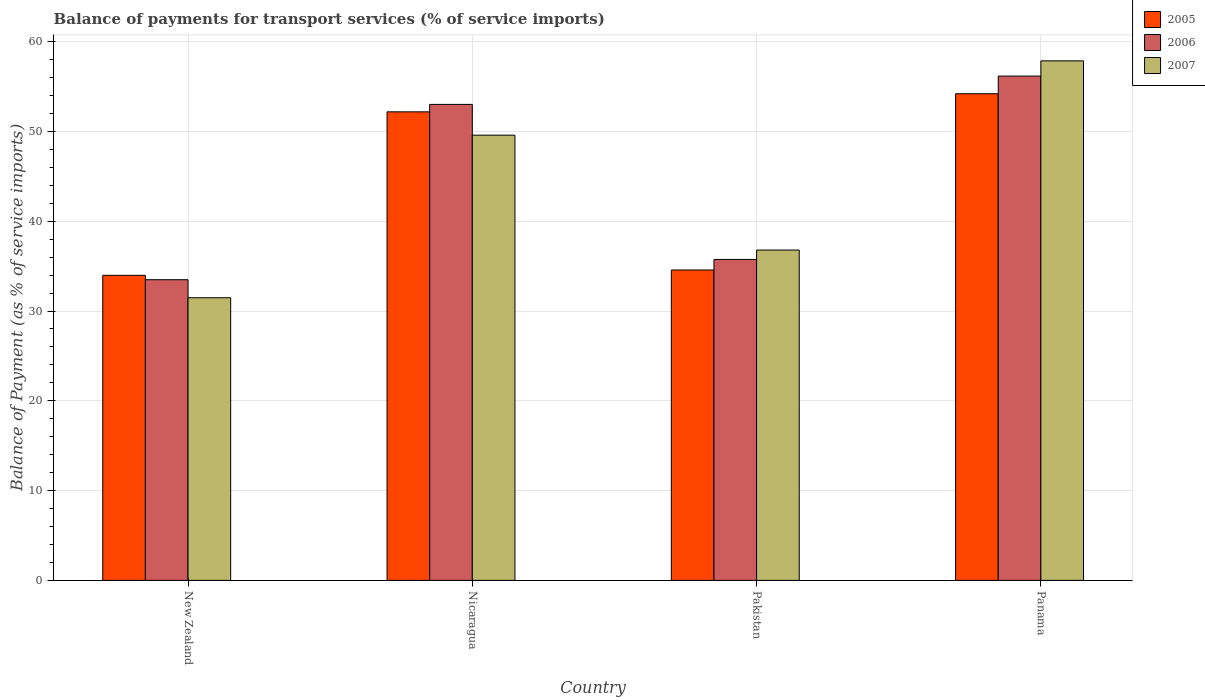How many different coloured bars are there?
Offer a very short reply. 3. Are the number of bars on each tick of the X-axis equal?
Give a very brief answer. Yes. How many bars are there on the 1st tick from the left?
Offer a terse response. 3. How many bars are there on the 1st tick from the right?
Give a very brief answer. 3. What is the label of the 2nd group of bars from the left?
Make the answer very short. Nicaragua. What is the balance of payments for transport services in 2005 in Panama?
Your response must be concise. 54.2. Across all countries, what is the maximum balance of payments for transport services in 2006?
Make the answer very short. 56.17. Across all countries, what is the minimum balance of payments for transport services in 2007?
Ensure brevity in your answer.  31.48. In which country was the balance of payments for transport services in 2005 maximum?
Your answer should be compact. Panama. In which country was the balance of payments for transport services in 2006 minimum?
Offer a very short reply. New Zealand. What is the total balance of payments for transport services in 2006 in the graph?
Provide a short and direct response. 178.42. What is the difference between the balance of payments for transport services in 2006 in Nicaragua and that in Panama?
Offer a terse response. -3.15. What is the difference between the balance of payments for transport services in 2006 in Pakistan and the balance of payments for transport services in 2007 in New Zealand?
Your response must be concise. 4.27. What is the average balance of payments for transport services in 2007 per country?
Provide a short and direct response. 43.93. What is the difference between the balance of payments for transport services of/in 2006 and balance of payments for transport services of/in 2005 in Nicaragua?
Make the answer very short. 0.83. In how many countries, is the balance of payments for transport services in 2006 greater than 54 %?
Provide a short and direct response. 1. What is the ratio of the balance of payments for transport services in 2007 in Pakistan to that in Panama?
Provide a succinct answer. 0.64. Is the balance of payments for transport services in 2006 in New Zealand less than that in Pakistan?
Your response must be concise. Yes. What is the difference between the highest and the second highest balance of payments for transport services in 2007?
Provide a short and direct response. 21.07. What is the difference between the highest and the lowest balance of payments for transport services in 2005?
Give a very brief answer. 20.22. What does the 2nd bar from the left in Nicaragua represents?
Ensure brevity in your answer.  2006. Is it the case that in every country, the sum of the balance of payments for transport services in 2006 and balance of payments for transport services in 2005 is greater than the balance of payments for transport services in 2007?
Your answer should be compact. Yes. What is the difference between two consecutive major ticks on the Y-axis?
Keep it short and to the point. 10. Where does the legend appear in the graph?
Your answer should be compact. Top right. How are the legend labels stacked?
Provide a succinct answer. Vertical. What is the title of the graph?
Your answer should be compact. Balance of payments for transport services (% of service imports). Does "1966" appear as one of the legend labels in the graph?
Offer a terse response. No. What is the label or title of the Y-axis?
Keep it short and to the point. Balance of Payment (as % of service imports). What is the Balance of Payment (as % of service imports) of 2005 in New Zealand?
Provide a succinct answer. 33.98. What is the Balance of Payment (as % of service imports) of 2006 in New Zealand?
Make the answer very short. 33.49. What is the Balance of Payment (as % of service imports) in 2007 in New Zealand?
Your answer should be compact. 31.48. What is the Balance of Payment (as % of service imports) of 2005 in Nicaragua?
Offer a terse response. 52.19. What is the Balance of Payment (as % of service imports) of 2006 in Nicaragua?
Ensure brevity in your answer.  53.01. What is the Balance of Payment (as % of service imports) in 2007 in Nicaragua?
Make the answer very short. 49.59. What is the Balance of Payment (as % of service imports) in 2005 in Pakistan?
Give a very brief answer. 34.57. What is the Balance of Payment (as % of service imports) of 2006 in Pakistan?
Your answer should be very brief. 35.75. What is the Balance of Payment (as % of service imports) in 2007 in Pakistan?
Your response must be concise. 36.79. What is the Balance of Payment (as % of service imports) in 2005 in Panama?
Make the answer very short. 54.2. What is the Balance of Payment (as % of service imports) in 2006 in Panama?
Offer a terse response. 56.17. What is the Balance of Payment (as % of service imports) of 2007 in Panama?
Your answer should be very brief. 57.86. Across all countries, what is the maximum Balance of Payment (as % of service imports) in 2005?
Keep it short and to the point. 54.2. Across all countries, what is the maximum Balance of Payment (as % of service imports) in 2006?
Provide a succinct answer. 56.17. Across all countries, what is the maximum Balance of Payment (as % of service imports) of 2007?
Provide a succinct answer. 57.86. Across all countries, what is the minimum Balance of Payment (as % of service imports) in 2005?
Your answer should be compact. 33.98. Across all countries, what is the minimum Balance of Payment (as % of service imports) of 2006?
Provide a succinct answer. 33.49. Across all countries, what is the minimum Balance of Payment (as % of service imports) of 2007?
Your answer should be compact. 31.48. What is the total Balance of Payment (as % of service imports) in 2005 in the graph?
Ensure brevity in your answer.  174.94. What is the total Balance of Payment (as % of service imports) in 2006 in the graph?
Keep it short and to the point. 178.42. What is the total Balance of Payment (as % of service imports) in 2007 in the graph?
Offer a terse response. 175.72. What is the difference between the Balance of Payment (as % of service imports) of 2005 in New Zealand and that in Nicaragua?
Offer a very short reply. -18.21. What is the difference between the Balance of Payment (as % of service imports) in 2006 in New Zealand and that in Nicaragua?
Provide a short and direct response. -19.53. What is the difference between the Balance of Payment (as % of service imports) in 2007 in New Zealand and that in Nicaragua?
Your response must be concise. -18.11. What is the difference between the Balance of Payment (as % of service imports) in 2005 in New Zealand and that in Pakistan?
Provide a succinct answer. -0.59. What is the difference between the Balance of Payment (as % of service imports) of 2006 in New Zealand and that in Pakistan?
Make the answer very short. -2.26. What is the difference between the Balance of Payment (as % of service imports) of 2007 in New Zealand and that in Pakistan?
Your answer should be very brief. -5.31. What is the difference between the Balance of Payment (as % of service imports) in 2005 in New Zealand and that in Panama?
Provide a short and direct response. -20.22. What is the difference between the Balance of Payment (as % of service imports) of 2006 in New Zealand and that in Panama?
Provide a short and direct response. -22.68. What is the difference between the Balance of Payment (as % of service imports) of 2007 in New Zealand and that in Panama?
Ensure brevity in your answer.  -26.38. What is the difference between the Balance of Payment (as % of service imports) in 2005 in Nicaragua and that in Pakistan?
Give a very brief answer. 17.61. What is the difference between the Balance of Payment (as % of service imports) of 2006 in Nicaragua and that in Pakistan?
Your answer should be compact. 17.27. What is the difference between the Balance of Payment (as % of service imports) in 2007 in Nicaragua and that in Pakistan?
Keep it short and to the point. 12.8. What is the difference between the Balance of Payment (as % of service imports) in 2005 in Nicaragua and that in Panama?
Keep it short and to the point. -2.02. What is the difference between the Balance of Payment (as % of service imports) in 2006 in Nicaragua and that in Panama?
Your answer should be very brief. -3.15. What is the difference between the Balance of Payment (as % of service imports) of 2007 in Nicaragua and that in Panama?
Your answer should be very brief. -8.28. What is the difference between the Balance of Payment (as % of service imports) of 2005 in Pakistan and that in Panama?
Your answer should be compact. -19.63. What is the difference between the Balance of Payment (as % of service imports) in 2006 in Pakistan and that in Panama?
Ensure brevity in your answer.  -20.42. What is the difference between the Balance of Payment (as % of service imports) in 2007 in Pakistan and that in Panama?
Make the answer very short. -21.07. What is the difference between the Balance of Payment (as % of service imports) of 2005 in New Zealand and the Balance of Payment (as % of service imports) of 2006 in Nicaragua?
Your answer should be compact. -19.03. What is the difference between the Balance of Payment (as % of service imports) of 2005 in New Zealand and the Balance of Payment (as % of service imports) of 2007 in Nicaragua?
Your answer should be compact. -15.61. What is the difference between the Balance of Payment (as % of service imports) in 2006 in New Zealand and the Balance of Payment (as % of service imports) in 2007 in Nicaragua?
Your answer should be very brief. -16.1. What is the difference between the Balance of Payment (as % of service imports) in 2005 in New Zealand and the Balance of Payment (as % of service imports) in 2006 in Pakistan?
Offer a terse response. -1.77. What is the difference between the Balance of Payment (as % of service imports) of 2005 in New Zealand and the Balance of Payment (as % of service imports) of 2007 in Pakistan?
Give a very brief answer. -2.81. What is the difference between the Balance of Payment (as % of service imports) of 2006 in New Zealand and the Balance of Payment (as % of service imports) of 2007 in Pakistan?
Provide a short and direct response. -3.3. What is the difference between the Balance of Payment (as % of service imports) in 2005 in New Zealand and the Balance of Payment (as % of service imports) in 2006 in Panama?
Give a very brief answer. -22.19. What is the difference between the Balance of Payment (as % of service imports) of 2005 in New Zealand and the Balance of Payment (as % of service imports) of 2007 in Panama?
Your response must be concise. -23.88. What is the difference between the Balance of Payment (as % of service imports) of 2006 in New Zealand and the Balance of Payment (as % of service imports) of 2007 in Panama?
Your answer should be very brief. -24.38. What is the difference between the Balance of Payment (as % of service imports) in 2005 in Nicaragua and the Balance of Payment (as % of service imports) in 2006 in Pakistan?
Your answer should be compact. 16.44. What is the difference between the Balance of Payment (as % of service imports) in 2005 in Nicaragua and the Balance of Payment (as % of service imports) in 2007 in Pakistan?
Offer a very short reply. 15.39. What is the difference between the Balance of Payment (as % of service imports) of 2006 in Nicaragua and the Balance of Payment (as % of service imports) of 2007 in Pakistan?
Your answer should be very brief. 16.22. What is the difference between the Balance of Payment (as % of service imports) of 2005 in Nicaragua and the Balance of Payment (as % of service imports) of 2006 in Panama?
Provide a succinct answer. -3.98. What is the difference between the Balance of Payment (as % of service imports) of 2005 in Nicaragua and the Balance of Payment (as % of service imports) of 2007 in Panama?
Offer a very short reply. -5.68. What is the difference between the Balance of Payment (as % of service imports) in 2006 in Nicaragua and the Balance of Payment (as % of service imports) in 2007 in Panama?
Make the answer very short. -4.85. What is the difference between the Balance of Payment (as % of service imports) of 2005 in Pakistan and the Balance of Payment (as % of service imports) of 2006 in Panama?
Make the answer very short. -21.6. What is the difference between the Balance of Payment (as % of service imports) of 2005 in Pakistan and the Balance of Payment (as % of service imports) of 2007 in Panama?
Your answer should be very brief. -23.29. What is the difference between the Balance of Payment (as % of service imports) in 2006 in Pakistan and the Balance of Payment (as % of service imports) in 2007 in Panama?
Provide a short and direct response. -22.12. What is the average Balance of Payment (as % of service imports) of 2005 per country?
Offer a terse response. 43.74. What is the average Balance of Payment (as % of service imports) in 2006 per country?
Offer a terse response. 44.6. What is the average Balance of Payment (as % of service imports) in 2007 per country?
Ensure brevity in your answer.  43.93. What is the difference between the Balance of Payment (as % of service imports) of 2005 and Balance of Payment (as % of service imports) of 2006 in New Zealand?
Your response must be concise. 0.49. What is the difference between the Balance of Payment (as % of service imports) of 2005 and Balance of Payment (as % of service imports) of 2007 in New Zealand?
Make the answer very short. 2.5. What is the difference between the Balance of Payment (as % of service imports) of 2006 and Balance of Payment (as % of service imports) of 2007 in New Zealand?
Provide a short and direct response. 2.01. What is the difference between the Balance of Payment (as % of service imports) of 2005 and Balance of Payment (as % of service imports) of 2006 in Nicaragua?
Provide a succinct answer. -0.83. What is the difference between the Balance of Payment (as % of service imports) in 2005 and Balance of Payment (as % of service imports) in 2007 in Nicaragua?
Ensure brevity in your answer.  2.6. What is the difference between the Balance of Payment (as % of service imports) in 2006 and Balance of Payment (as % of service imports) in 2007 in Nicaragua?
Provide a short and direct response. 3.43. What is the difference between the Balance of Payment (as % of service imports) of 2005 and Balance of Payment (as % of service imports) of 2006 in Pakistan?
Your answer should be compact. -1.17. What is the difference between the Balance of Payment (as % of service imports) of 2005 and Balance of Payment (as % of service imports) of 2007 in Pakistan?
Keep it short and to the point. -2.22. What is the difference between the Balance of Payment (as % of service imports) in 2006 and Balance of Payment (as % of service imports) in 2007 in Pakistan?
Make the answer very short. -1.04. What is the difference between the Balance of Payment (as % of service imports) of 2005 and Balance of Payment (as % of service imports) of 2006 in Panama?
Provide a short and direct response. -1.97. What is the difference between the Balance of Payment (as % of service imports) in 2005 and Balance of Payment (as % of service imports) in 2007 in Panama?
Give a very brief answer. -3.66. What is the difference between the Balance of Payment (as % of service imports) of 2006 and Balance of Payment (as % of service imports) of 2007 in Panama?
Provide a short and direct response. -1.7. What is the ratio of the Balance of Payment (as % of service imports) of 2005 in New Zealand to that in Nicaragua?
Provide a short and direct response. 0.65. What is the ratio of the Balance of Payment (as % of service imports) of 2006 in New Zealand to that in Nicaragua?
Offer a terse response. 0.63. What is the ratio of the Balance of Payment (as % of service imports) of 2007 in New Zealand to that in Nicaragua?
Keep it short and to the point. 0.63. What is the ratio of the Balance of Payment (as % of service imports) of 2005 in New Zealand to that in Pakistan?
Provide a short and direct response. 0.98. What is the ratio of the Balance of Payment (as % of service imports) in 2006 in New Zealand to that in Pakistan?
Your answer should be compact. 0.94. What is the ratio of the Balance of Payment (as % of service imports) in 2007 in New Zealand to that in Pakistan?
Offer a very short reply. 0.86. What is the ratio of the Balance of Payment (as % of service imports) of 2005 in New Zealand to that in Panama?
Ensure brevity in your answer.  0.63. What is the ratio of the Balance of Payment (as % of service imports) of 2006 in New Zealand to that in Panama?
Make the answer very short. 0.6. What is the ratio of the Balance of Payment (as % of service imports) in 2007 in New Zealand to that in Panama?
Offer a very short reply. 0.54. What is the ratio of the Balance of Payment (as % of service imports) in 2005 in Nicaragua to that in Pakistan?
Offer a terse response. 1.51. What is the ratio of the Balance of Payment (as % of service imports) in 2006 in Nicaragua to that in Pakistan?
Provide a short and direct response. 1.48. What is the ratio of the Balance of Payment (as % of service imports) in 2007 in Nicaragua to that in Pakistan?
Offer a very short reply. 1.35. What is the ratio of the Balance of Payment (as % of service imports) of 2005 in Nicaragua to that in Panama?
Ensure brevity in your answer.  0.96. What is the ratio of the Balance of Payment (as % of service imports) in 2006 in Nicaragua to that in Panama?
Your answer should be compact. 0.94. What is the ratio of the Balance of Payment (as % of service imports) of 2007 in Nicaragua to that in Panama?
Provide a short and direct response. 0.86. What is the ratio of the Balance of Payment (as % of service imports) of 2005 in Pakistan to that in Panama?
Make the answer very short. 0.64. What is the ratio of the Balance of Payment (as % of service imports) in 2006 in Pakistan to that in Panama?
Make the answer very short. 0.64. What is the ratio of the Balance of Payment (as % of service imports) of 2007 in Pakistan to that in Panama?
Ensure brevity in your answer.  0.64. What is the difference between the highest and the second highest Balance of Payment (as % of service imports) in 2005?
Provide a short and direct response. 2.02. What is the difference between the highest and the second highest Balance of Payment (as % of service imports) in 2006?
Your answer should be compact. 3.15. What is the difference between the highest and the second highest Balance of Payment (as % of service imports) of 2007?
Keep it short and to the point. 8.28. What is the difference between the highest and the lowest Balance of Payment (as % of service imports) in 2005?
Offer a terse response. 20.22. What is the difference between the highest and the lowest Balance of Payment (as % of service imports) in 2006?
Your answer should be very brief. 22.68. What is the difference between the highest and the lowest Balance of Payment (as % of service imports) in 2007?
Offer a very short reply. 26.38. 